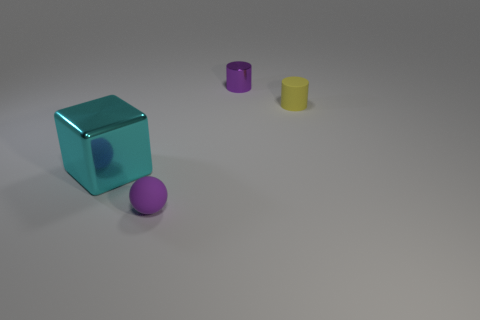What is the color of the cylinder to the left of the small cylinder that is in front of the purple thing behind the big cyan block?
Give a very brief answer. Purple. How many cyan objects are large metal objects or tiny matte cubes?
Provide a succinct answer. 1. How many other objects are there of the same size as the purple shiny thing?
Your answer should be compact. 2. How many tiny gray shiny cubes are there?
Ensure brevity in your answer.  0. Is there any other thing that is the same shape as the purple rubber thing?
Your answer should be compact. No. Do the tiny purple thing that is left of the tiny purple cylinder and the object that is on the right side of the purple cylinder have the same material?
Ensure brevity in your answer.  Yes. What is the small yellow cylinder made of?
Your answer should be compact. Rubber. What number of tiny purple objects have the same material as the small yellow object?
Provide a succinct answer. 1. How many rubber objects are tiny things or large brown cylinders?
Provide a succinct answer. 2. Does the purple thing that is behind the metallic block have the same shape as the small matte object that is behind the big cyan shiny cube?
Provide a short and direct response. Yes. 